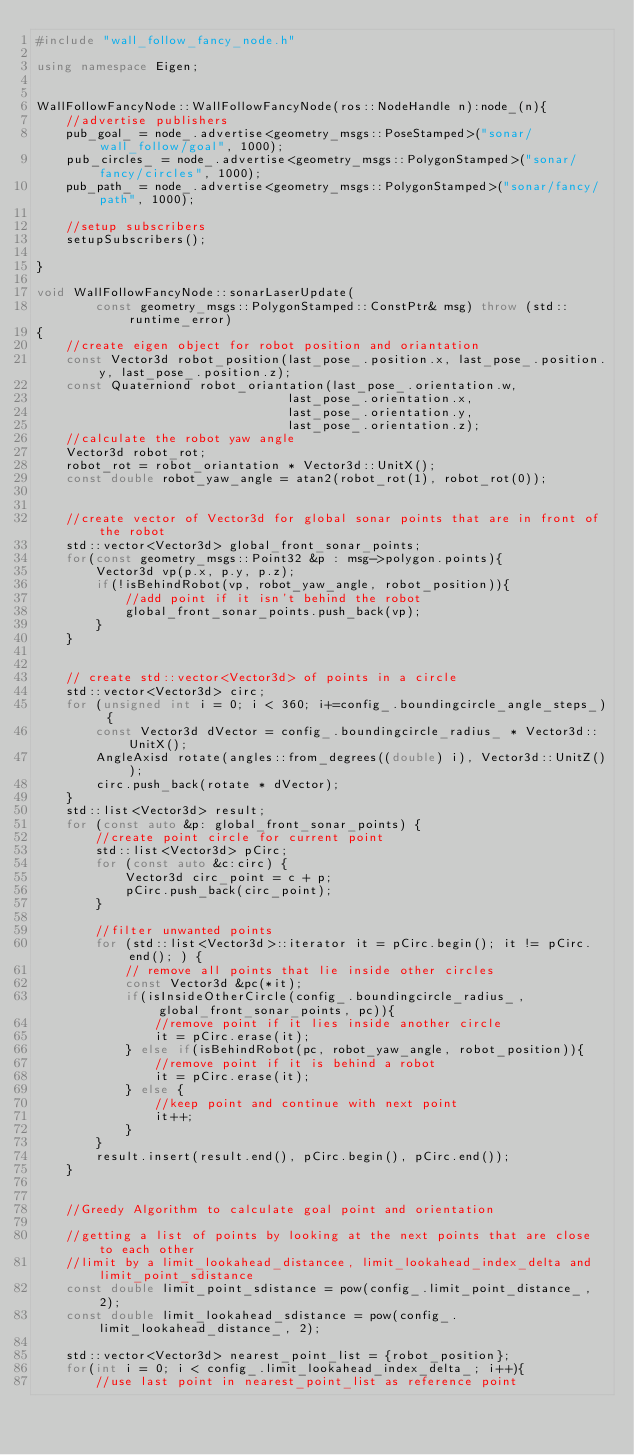Convert code to text. <code><loc_0><loc_0><loc_500><loc_500><_C++_>#include "wall_follow_fancy_node.h"

using namespace Eigen;


WallFollowFancyNode::WallFollowFancyNode(ros::NodeHandle n):node_(n){
    //advertise publishers
    pub_goal_ = node_.advertise<geometry_msgs::PoseStamped>("sonar/wall_follow/goal", 1000);
    pub_circles_ = node_.advertise<geometry_msgs::PolygonStamped>("sonar/fancy/circles", 1000);
    pub_path_ = node_.advertise<geometry_msgs::PolygonStamped>("sonar/fancy/path", 1000);

    //setup subscribers
    setupSubscribers();

}

void WallFollowFancyNode::sonarLaserUpdate(
        const geometry_msgs::PolygonStamped::ConstPtr& msg) throw (std::runtime_error)
{
    //create eigen object for robot position and oriantation
    const Vector3d robot_position(last_pose_.position.x, last_pose_.position.y, last_pose_.position.z);
    const Quaterniond robot_oriantation(last_pose_.orientation.w,
                                  last_pose_.orientation.x,
                                  last_pose_.orientation.y,
                                  last_pose_.orientation.z);
    //calculate the robot yaw angle
    Vector3d robot_rot;
    robot_rot = robot_oriantation * Vector3d::UnitX();
    const double robot_yaw_angle = atan2(robot_rot(1), robot_rot(0));


    //create vector of Vector3d for global sonar points that are in front of the robot
    std::vector<Vector3d> global_front_sonar_points;
    for(const geometry_msgs::Point32 &p : msg->polygon.points){
        Vector3d vp(p.x, p.y, p.z);
        if(!isBehindRobot(vp, robot_yaw_angle, robot_position)){
            //add point if it isn't behind the robot
            global_front_sonar_points.push_back(vp);
        }
    }


    // create std::vector<Vector3d> of points in a circle
    std::vector<Vector3d> circ;
    for (unsigned int i = 0; i < 360; i+=config_.boundingcircle_angle_steps_) {
        const Vector3d dVector = config_.boundingcircle_radius_ * Vector3d::UnitX();
        AngleAxisd rotate(angles::from_degrees((double) i), Vector3d::UnitZ());
        circ.push_back(rotate * dVector);
    }
    std::list<Vector3d> result;
    for (const auto &p: global_front_sonar_points) {
        //create point circle for current point
        std::list<Vector3d> pCirc;
        for (const auto &c:circ) {
            Vector3d circ_point = c + p;
            pCirc.push_back(circ_point);
        }

        //filter unwanted points
        for (std::list<Vector3d>::iterator it = pCirc.begin(); it != pCirc.end(); ) {
            // remove all points that lie inside other circles
            const Vector3d &pc(*it);
            if(isInsideOtherCircle(config_.boundingcircle_radius_, global_front_sonar_points, pc)){
                //remove point if it lies inside another circle
                it = pCirc.erase(it);
            } else if(isBehindRobot(pc, robot_yaw_angle, robot_position)){
                //remove point if it is behind a robot
                it = pCirc.erase(it);
            } else {
                //keep point and continue with next point
                it++;
            }
        }
        result.insert(result.end(), pCirc.begin(), pCirc.end());
    }


    //Greedy Algorithm to calculate goal point and orientation

    //getting a list of points by looking at the next points that are close to each other
    //limit by a limit_lookahead_distancee, limit_lookahead_index_delta and limit_point_sdistance
    const double limit_point_sdistance = pow(config_.limit_point_distance_, 2);
    const double limit_lookahead_sdistance = pow(config_.limit_lookahead_distance_, 2);

    std::vector<Vector3d> nearest_point_list = {robot_position};
    for(int i = 0; i < config_.limit_lookahead_index_delta_; i++){
        //use last point in nearest_point_list as reference point</code> 